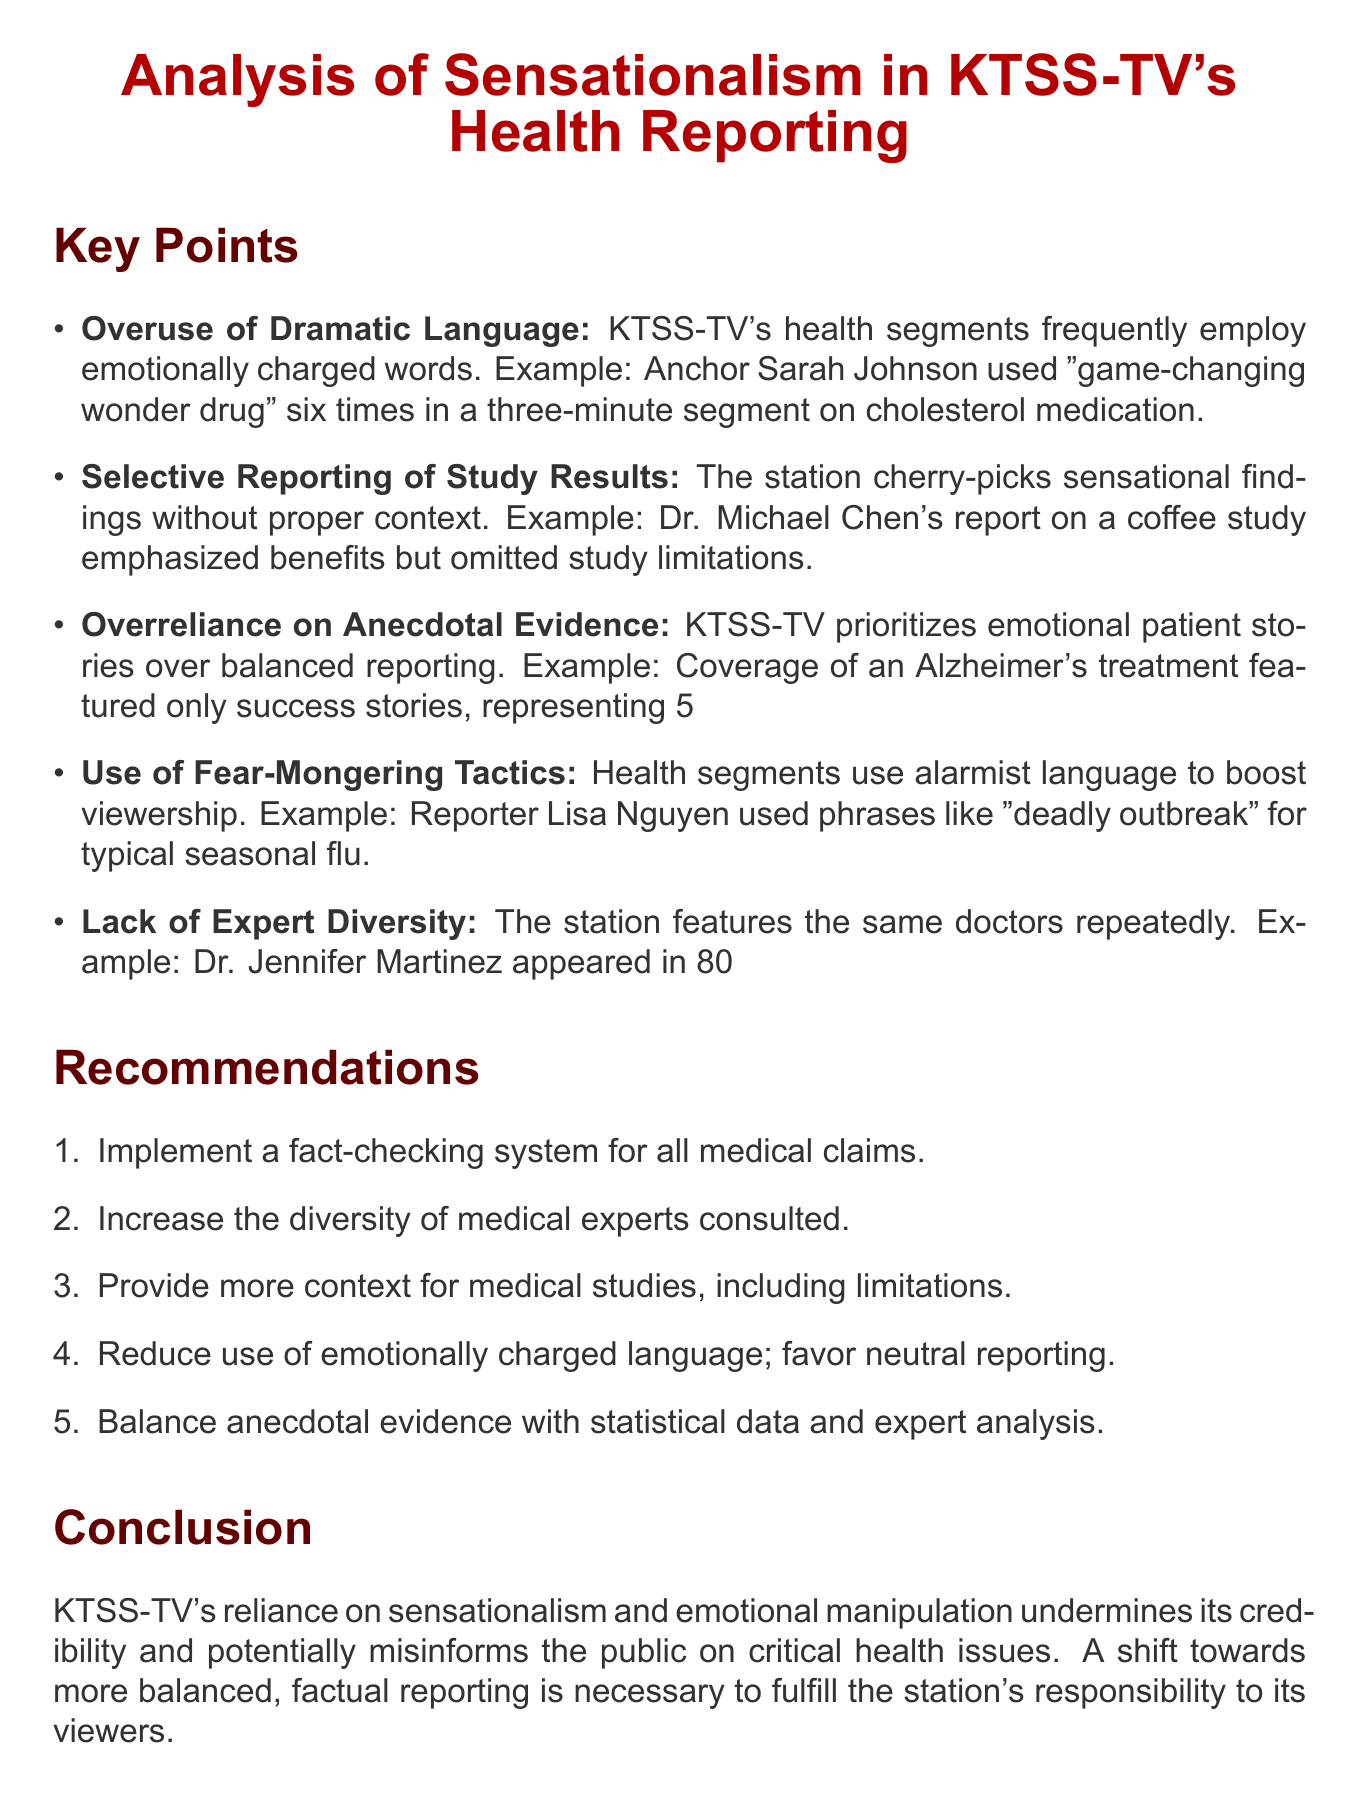What is the title of the memo? The title of the memo is presented prominently at the beginning, which is "Analysis of Sensationalism in KTSS-TV's Health Reporting."
Answer: Analysis of Sensationalism in KTSS-TV's Health Reporting How many examples are provided for the overuse of dramatic language? The section on overuse of dramatic language includes one specific example, which mentions Sarah Johnson's multiple uses of a particular phrase.
Answer: One Which doctor is mentioned most frequently in child health segments? The memo details that Dr. Jennifer Martinez has appeared in 80% of KTSS-TV's child health segments, making her the most frequently mentioned doctor.
Answer: Dr. Jennifer Martinez What phrase did reporter Lisa Nguyen use during flu season? The document cites the phrase “deadly outbreak” as an example of alarmist language used by reporter Lisa Nguyen.
Answer: deadly outbreak What percentage of trial participants represented the success stories featured in the Alzheimer's treatment coverage? It specifies that the success stories represented only 5% of the trial participants in the Alzheimer's treatment segment.
Answer: 5% What does the memo suggest to balance anecdotal evidence? The recommendations section states that anecdotal evidence should be balanced with statistical data and expert analysis.
Answer: statistical data and expert analysis What is one recommendation made in the memo regarding emotional language? The memo suggests reducing the use of emotionally charged language in favor of more neutral, factual reporting as a recommendation.
Answer: reduce the use of emotionally charged language What is the main conclusion about KTSS-TV's health reporting? The conclusion summarizes the overall view on KTSS-TV's reporting style, emphasizing that it undermines credibility and misinforms the public.
Answer: undermines its credibility and potentially misinforms the public What is the main focus of the memo? The memo focuses on analyzing the sensationalism in KTSS-TV's health reporting.
Answer: sensationalism in KTSS-TV's health reporting 